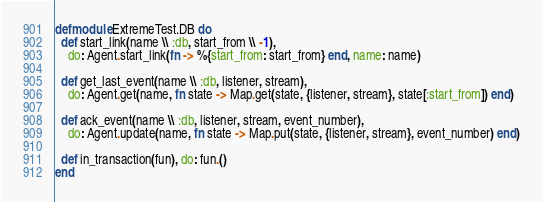Convert code to text. <code><loc_0><loc_0><loc_500><loc_500><_Elixir_>defmodule ExtremeTest.DB do
  def start_link(name \\ :db, start_from \\ -1),
    do: Agent.start_link(fn -> %{start_from: start_from} end, name: name)

  def get_last_event(name \\ :db, listener, stream),
    do: Agent.get(name, fn state -> Map.get(state, {listener, stream}, state[:start_from]) end)

  def ack_event(name \\ :db, listener, stream, event_number),
    do: Agent.update(name, fn state -> Map.put(state, {listener, stream}, event_number) end)

  def in_transaction(fun), do: fun.()
end
</code> 